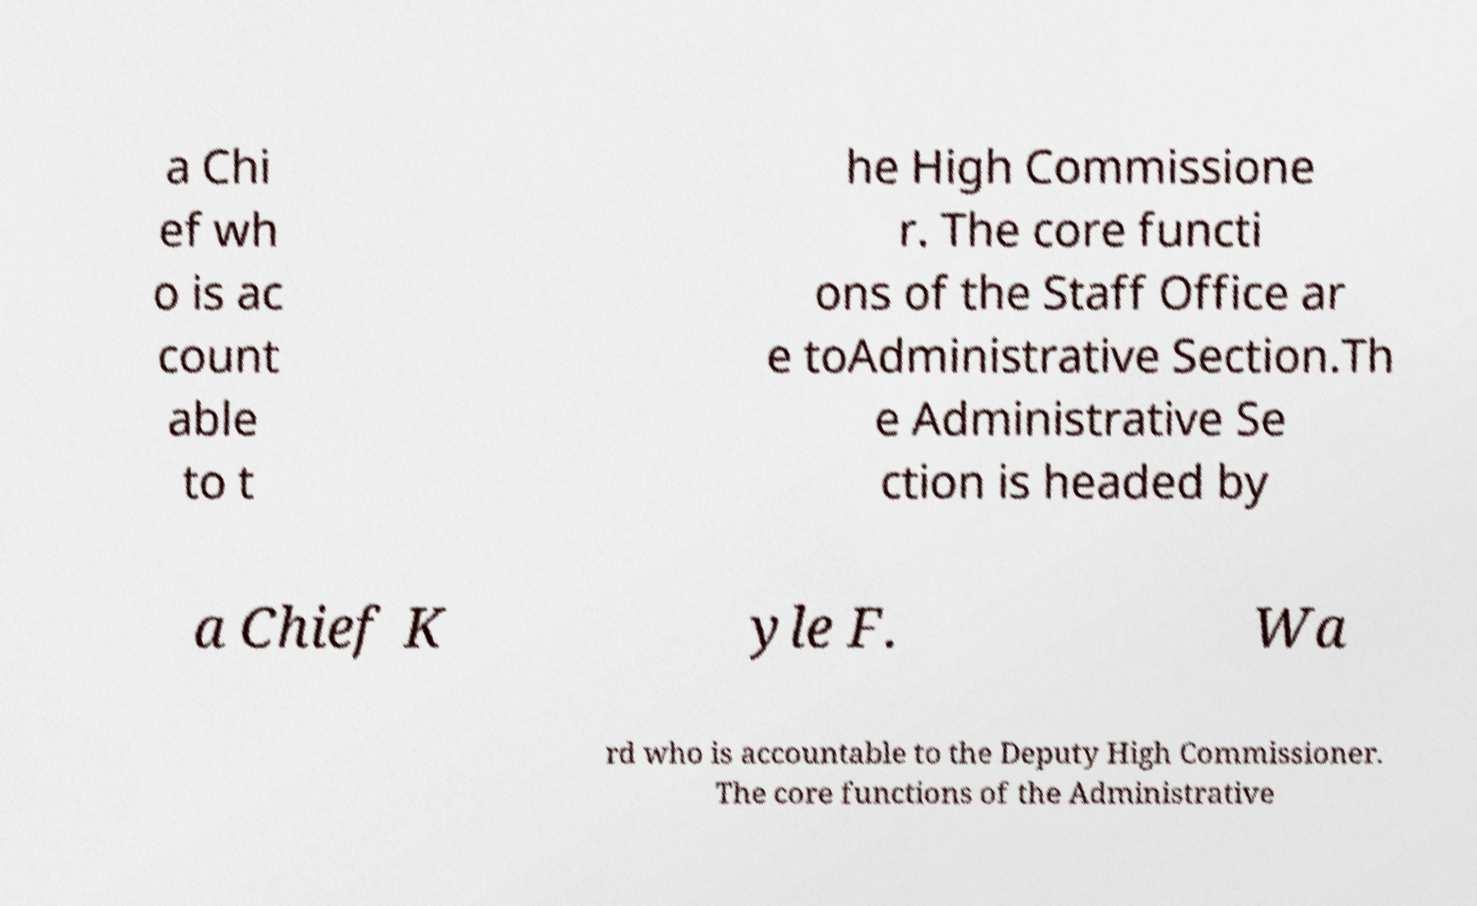Could you extract and type out the text from this image? a Chi ef wh o is ac count able to t he High Commissione r. The core functi ons of the Staff Office ar e toAdministrative Section.Th e Administrative Se ction is headed by a Chief K yle F. Wa rd who is accountable to the Deputy High Commissioner. The core functions of the Administrative 